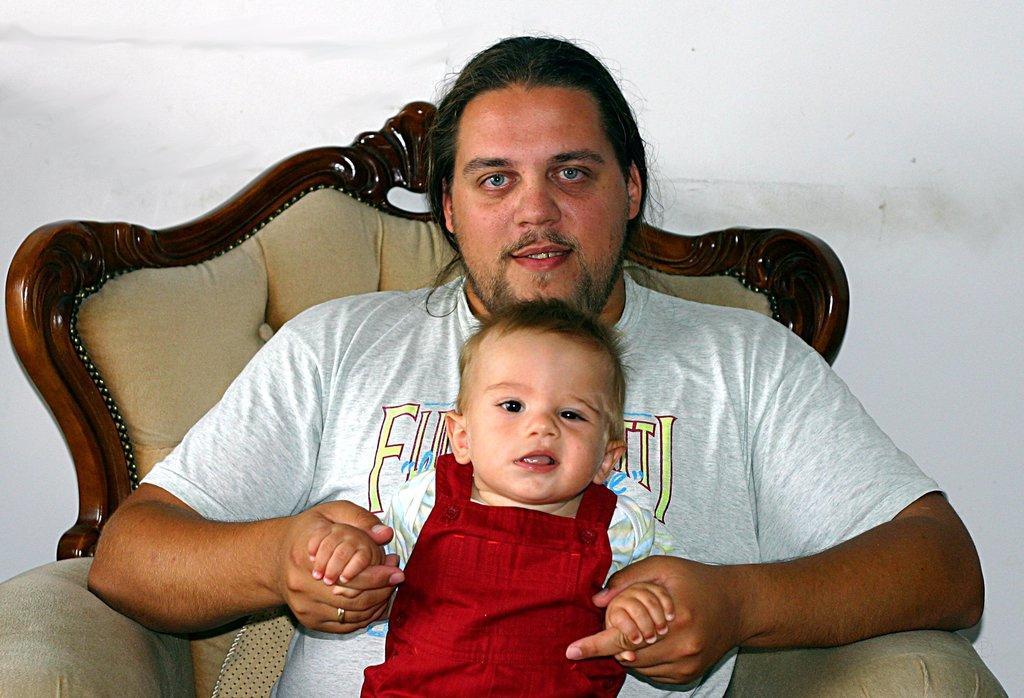Can you describe this image briefly? In this image I can see a person holding baby. He is sitting on the chair. The baby is wearing red and white color dress. Background is in white color. 